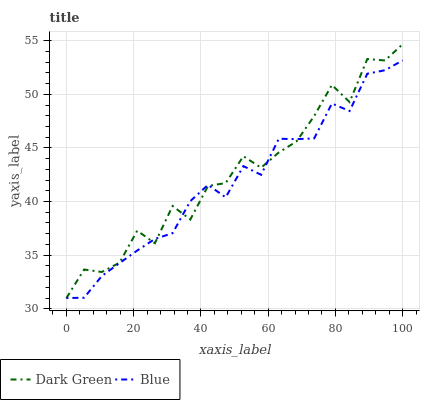Does Blue have the minimum area under the curve?
Answer yes or no. Yes. Does Dark Green have the maximum area under the curve?
Answer yes or no. Yes. Does Dark Green have the minimum area under the curve?
Answer yes or no. No. Is Blue the smoothest?
Answer yes or no. Yes. Is Dark Green the roughest?
Answer yes or no. Yes. Is Dark Green the smoothest?
Answer yes or no. No. Does Blue have the lowest value?
Answer yes or no. Yes. Does Dark Green have the highest value?
Answer yes or no. Yes. Does Blue intersect Dark Green?
Answer yes or no. Yes. Is Blue less than Dark Green?
Answer yes or no. No. Is Blue greater than Dark Green?
Answer yes or no. No. 